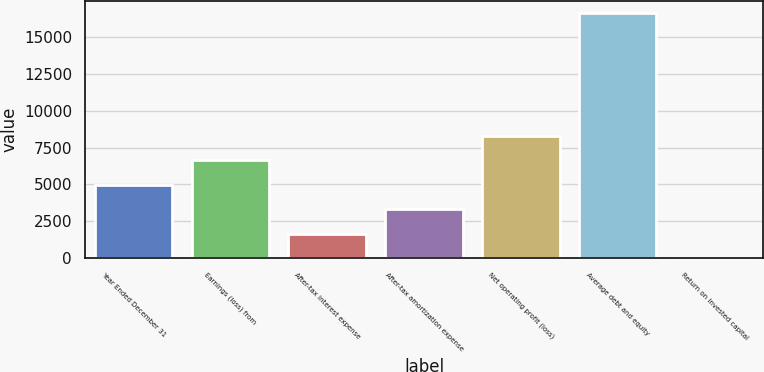<chart> <loc_0><loc_0><loc_500><loc_500><bar_chart><fcel>Year Ended December 31<fcel>Earnings (loss) from<fcel>After-tax interest expense<fcel>After-tax amortization expense<fcel>Net operating profit (loss)<fcel>Average debt and equity<fcel>Return on invested capital<nl><fcel>4988.35<fcel>6645.3<fcel>1674.45<fcel>3331.4<fcel>8302.25<fcel>16587<fcel>17.5<nl></chart> 